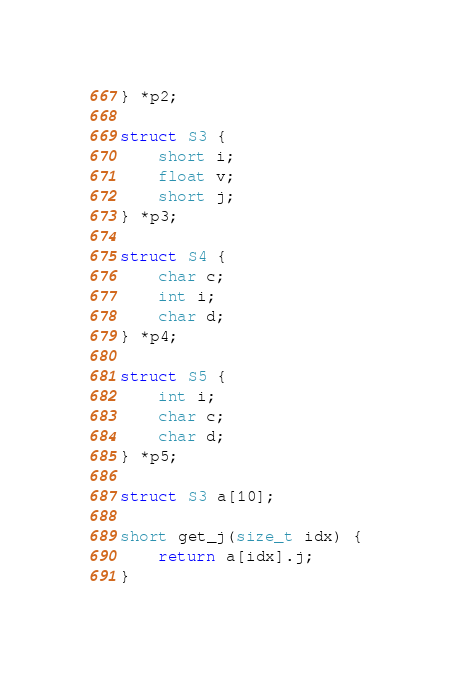<code> <loc_0><loc_0><loc_500><loc_500><_C_>} *p2;

struct S3 {
    short i;
    float v;
    short j;
} *p3;

struct S4 {
    char c;
    int i;
    char d;
} *p4;

struct S5 {
    int i;
    char c;
    char d;
} *p5;

struct S3 a[10];

short get_j(size_t idx) {
    return a[idx].j;
}
</code> 